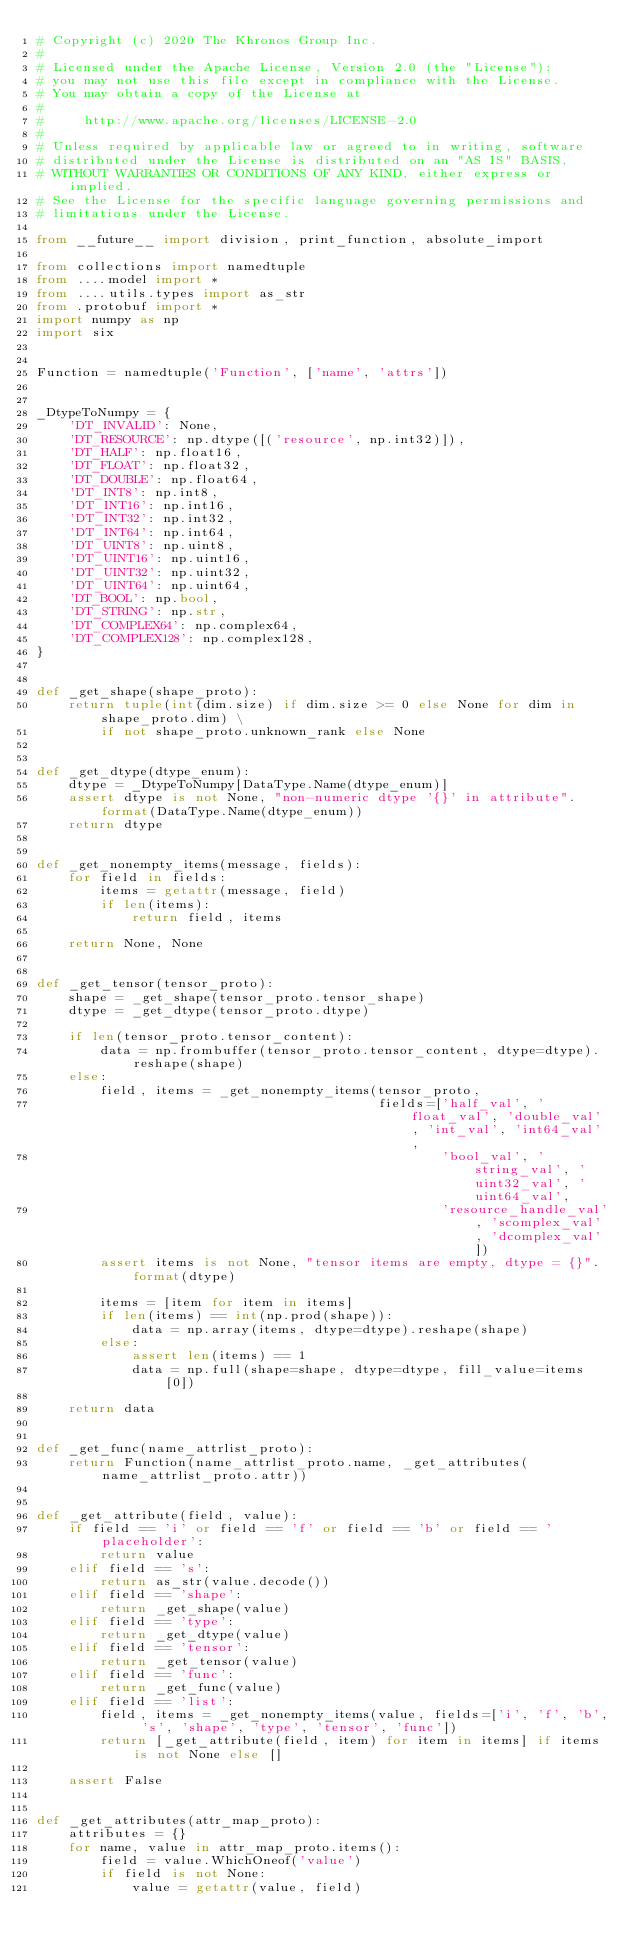Convert code to text. <code><loc_0><loc_0><loc_500><loc_500><_Python_># Copyright (c) 2020 The Khronos Group Inc.
#
# Licensed under the Apache License, Version 2.0 (the "License");
# you may not use this file except in compliance with the License.
# You may obtain a copy of the License at
#
#     http://www.apache.org/licenses/LICENSE-2.0
#
# Unless required by applicable law or agreed to in writing, software
# distributed under the License is distributed on an "AS IS" BASIS,
# WITHOUT WARRANTIES OR CONDITIONS OF ANY KIND, either express or implied.
# See the License for the specific language governing permissions and
# limitations under the License.

from __future__ import division, print_function, absolute_import

from collections import namedtuple
from ....model import *
from ....utils.types import as_str
from .protobuf import *
import numpy as np
import six


Function = namedtuple('Function', ['name', 'attrs'])


_DtypeToNumpy = {
    'DT_INVALID': None,
    'DT_RESOURCE': np.dtype([('resource', np.int32)]),
    'DT_HALF': np.float16,
    'DT_FLOAT': np.float32,
    'DT_DOUBLE': np.float64,
    'DT_INT8': np.int8,
    'DT_INT16': np.int16,
    'DT_INT32': np.int32,
    'DT_INT64': np.int64,
    'DT_UINT8': np.uint8,
    'DT_UINT16': np.uint16,
    'DT_UINT32': np.uint32,
    'DT_UINT64': np.uint64,
    'DT_BOOL': np.bool,
    'DT_STRING': np.str,
    'DT_COMPLEX64': np.complex64,
    'DT_COMPLEX128': np.complex128,
}


def _get_shape(shape_proto):
    return tuple(int(dim.size) if dim.size >= 0 else None for dim in shape_proto.dim) \
        if not shape_proto.unknown_rank else None


def _get_dtype(dtype_enum):
    dtype = _DtypeToNumpy[DataType.Name(dtype_enum)]
    assert dtype is not None, "non-numeric dtype '{}' in attribute".format(DataType.Name(dtype_enum))
    return dtype


def _get_nonempty_items(message, fields):
    for field in fields:
        items = getattr(message, field)
        if len(items):
            return field, items

    return None, None


def _get_tensor(tensor_proto):
    shape = _get_shape(tensor_proto.tensor_shape)
    dtype = _get_dtype(tensor_proto.dtype)

    if len(tensor_proto.tensor_content):
        data = np.frombuffer(tensor_proto.tensor_content, dtype=dtype).reshape(shape)
    else:
        field, items = _get_nonempty_items(tensor_proto,
                                           fields=['half_val', 'float_val', 'double_val', 'int_val', 'int64_val',
                                                   'bool_val', 'string_val', 'uint32_val', 'uint64_val',
                                                   'resource_handle_val', 'scomplex_val', 'dcomplex_val'])
        assert items is not None, "tensor items are empty, dtype = {}".format(dtype)

        items = [item for item in items]
        if len(items) == int(np.prod(shape)):
            data = np.array(items, dtype=dtype).reshape(shape)
        else:
            assert len(items) == 1
            data = np.full(shape=shape, dtype=dtype, fill_value=items[0])

    return data


def _get_func(name_attrlist_proto):
    return Function(name_attrlist_proto.name, _get_attributes(name_attrlist_proto.attr))


def _get_attribute(field, value):
    if field == 'i' or field == 'f' or field == 'b' or field == 'placeholder':
        return value
    elif field == 's':
        return as_str(value.decode())
    elif field == 'shape':
        return _get_shape(value)
    elif field == 'type':
        return _get_dtype(value)
    elif field == 'tensor':
        return _get_tensor(value)
    elif field == 'func':
        return _get_func(value)
    elif field == 'list':
        field, items = _get_nonempty_items(value, fields=['i', 'f', 'b', 's', 'shape', 'type', 'tensor', 'func'])
        return [_get_attribute(field, item) for item in items] if items is not None else []

    assert False


def _get_attributes(attr_map_proto):
    attributes = {}
    for name, value in attr_map_proto.items():
        field = value.WhichOneof('value')
        if field is not None:
            value = getattr(value, field)</code> 